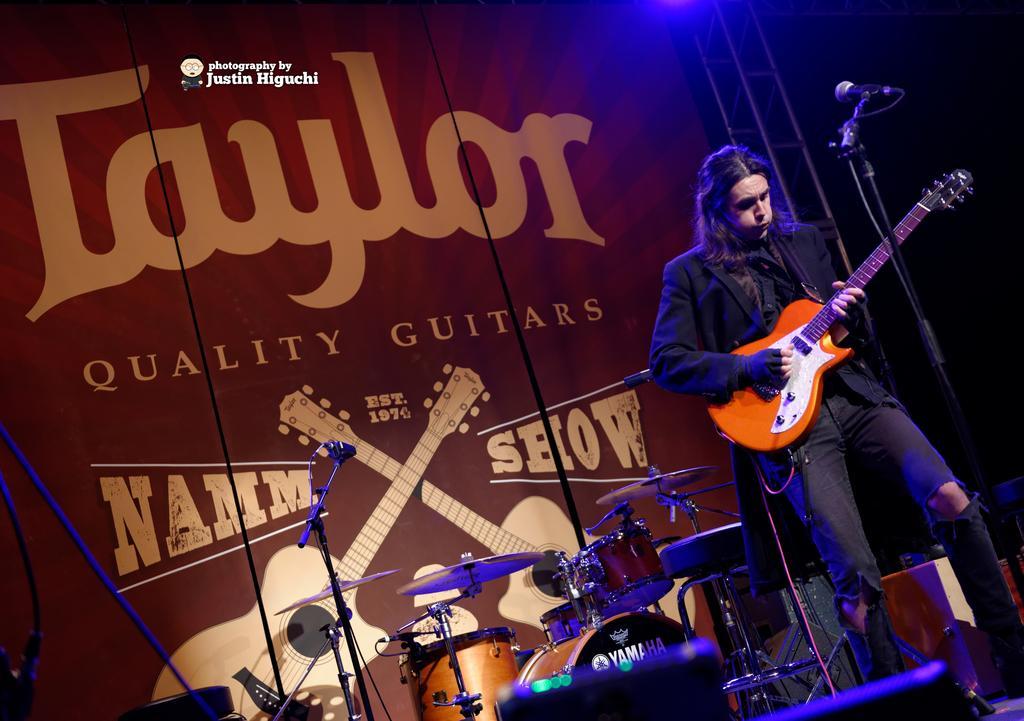Can you describe this image briefly? The man in black suit is playing a guitar. This is mic with holder. These are musical instruments. A poster of a musical instrument. 